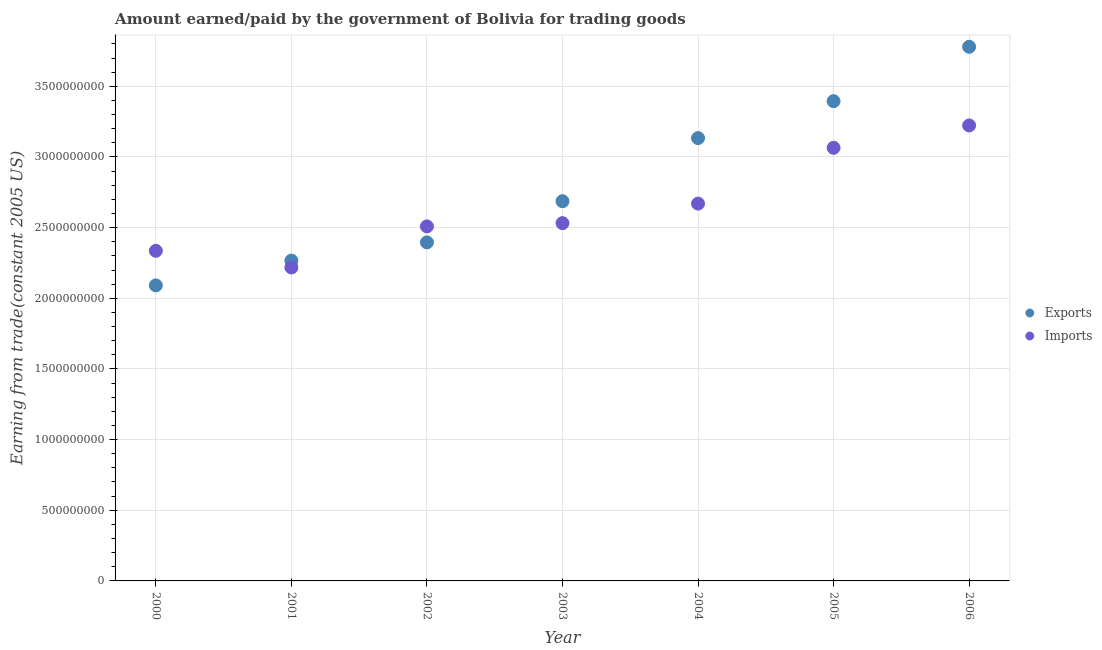Is the number of dotlines equal to the number of legend labels?
Make the answer very short. Yes. What is the amount paid for imports in 2000?
Offer a terse response. 2.34e+09. Across all years, what is the maximum amount paid for imports?
Give a very brief answer. 3.22e+09. Across all years, what is the minimum amount paid for imports?
Offer a very short reply. 2.22e+09. What is the total amount earned from exports in the graph?
Give a very brief answer. 1.97e+1. What is the difference between the amount paid for imports in 2000 and that in 2001?
Your answer should be compact. 1.18e+08. What is the difference between the amount earned from exports in 2003 and the amount paid for imports in 2002?
Provide a succinct answer. 1.78e+08. What is the average amount paid for imports per year?
Your answer should be compact. 2.65e+09. In the year 2006, what is the difference between the amount earned from exports and amount paid for imports?
Your answer should be compact. 5.57e+08. What is the ratio of the amount paid for imports in 2004 to that in 2005?
Make the answer very short. 0.87. Is the amount paid for imports in 2000 less than that in 2002?
Your response must be concise. Yes. What is the difference between the highest and the second highest amount earned from exports?
Your answer should be compact. 3.85e+08. What is the difference between the highest and the lowest amount earned from exports?
Offer a very short reply. 1.69e+09. Is the sum of the amount paid for imports in 2002 and 2005 greater than the maximum amount earned from exports across all years?
Ensure brevity in your answer.  Yes. Does the amount paid for imports monotonically increase over the years?
Ensure brevity in your answer.  No. How many dotlines are there?
Your answer should be compact. 2. How many years are there in the graph?
Your response must be concise. 7. What is the difference between two consecutive major ticks on the Y-axis?
Your answer should be compact. 5.00e+08. Does the graph contain any zero values?
Offer a very short reply. No. Does the graph contain grids?
Your answer should be very brief. Yes. Where does the legend appear in the graph?
Your response must be concise. Center right. How are the legend labels stacked?
Give a very brief answer. Vertical. What is the title of the graph?
Provide a succinct answer. Amount earned/paid by the government of Bolivia for trading goods. What is the label or title of the Y-axis?
Provide a short and direct response. Earning from trade(constant 2005 US). What is the Earning from trade(constant 2005 US) of Exports in 2000?
Your answer should be compact. 2.09e+09. What is the Earning from trade(constant 2005 US) in Imports in 2000?
Make the answer very short. 2.34e+09. What is the Earning from trade(constant 2005 US) of Exports in 2001?
Ensure brevity in your answer.  2.27e+09. What is the Earning from trade(constant 2005 US) in Imports in 2001?
Keep it short and to the point. 2.22e+09. What is the Earning from trade(constant 2005 US) of Exports in 2002?
Provide a short and direct response. 2.40e+09. What is the Earning from trade(constant 2005 US) of Imports in 2002?
Your answer should be very brief. 2.51e+09. What is the Earning from trade(constant 2005 US) of Exports in 2003?
Provide a succinct answer. 2.69e+09. What is the Earning from trade(constant 2005 US) of Imports in 2003?
Your response must be concise. 2.53e+09. What is the Earning from trade(constant 2005 US) of Exports in 2004?
Your answer should be very brief. 3.13e+09. What is the Earning from trade(constant 2005 US) in Imports in 2004?
Keep it short and to the point. 2.67e+09. What is the Earning from trade(constant 2005 US) in Exports in 2005?
Your answer should be very brief. 3.39e+09. What is the Earning from trade(constant 2005 US) of Imports in 2005?
Give a very brief answer. 3.06e+09. What is the Earning from trade(constant 2005 US) of Exports in 2006?
Make the answer very short. 3.78e+09. What is the Earning from trade(constant 2005 US) in Imports in 2006?
Your response must be concise. 3.22e+09. Across all years, what is the maximum Earning from trade(constant 2005 US) in Exports?
Your answer should be very brief. 3.78e+09. Across all years, what is the maximum Earning from trade(constant 2005 US) of Imports?
Provide a succinct answer. 3.22e+09. Across all years, what is the minimum Earning from trade(constant 2005 US) in Exports?
Your response must be concise. 2.09e+09. Across all years, what is the minimum Earning from trade(constant 2005 US) of Imports?
Provide a succinct answer. 2.22e+09. What is the total Earning from trade(constant 2005 US) in Exports in the graph?
Your response must be concise. 1.97e+1. What is the total Earning from trade(constant 2005 US) of Imports in the graph?
Ensure brevity in your answer.  1.86e+1. What is the difference between the Earning from trade(constant 2005 US) in Exports in 2000 and that in 2001?
Your answer should be compact. -1.75e+08. What is the difference between the Earning from trade(constant 2005 US) of Imports in 2000 and that in 2001?
Your response must be concise. 1.18e+08. What is the difference between the Earning from trade(constant 2005 US) in Exports in 2000 and that in 2002?
Your response must be concise. -3.04e+08. What is the difference between the Earning from trade(constant 2005 US) in Imports in 2000 and that in 2002?
Your response must be concise. -1.73e+08. What is the difference between the Earning from trade(constant 2005 US) in Exports in 2000 and that in 2003?
Give a very brief answer. -5.96e+08. What is the difference between the Earning from trade(constant 2005 US) in Imports in 2000 and that in 2003?
Provide a succinct answer. -1.96e+08. What is the difference between the Earning from trade(constant 2005 US) of Exports in 2000 and that in 2004?
Provide a succinct answer. -1.04e+09. What is the difference between the Earning from trade(constant 2005 US) of Imports in 2000 and that in 2004?
Provide a short and direct response. -3.34e+08. What is the difference between the Earning from trade(constant 2005 US) in Exports in 2000 and that in 2005?
Keep it short and to the point. -1.30e+09. What is the difference between the Earning from trade(constant 2005 US) of Imports in 2000 and that in 2005?
Your answer should be very brief. -7.29e+08. What is the difference between the Earning from trade(constant 2005 US) of Exports in 2000 and that in 2006?
Make the answer very short. -1.69e+09. What is the difference between the Earning from trade(constant 2005 US) in Imports in 2000 and that in 2006?
Make the answer very short. -8.87e+08. What is the difference between the Earning from trade(constant 2005 US) in Exports in 2001 and that in 2002?
Offer a terse response. -1.29e+08. What is the difference between the Earning from trade(constant 2005 US) in Imports in 2001 and that in 2002?
Your response must be concise. -2.90e+08. What is the difference between the Earning from trade(constant 2005 US) of Exports in 2001 and that in 2003?
Make the answer very short. -4.20e+08. What is the difference between the Earning from trade(constant 2005 US) in Imports in 2001 and that in 2003?
Your response must be concise. -3.13e+08. What is the difference between the Earning from trade(constant 2005 US) in Exports in 2001 and that in 2004?
Your answer should be compact. -8.67e+08. What is the difference between the Earning from trade(constant 2005 US) in Imports in 2001 and that in 2004?
Your answer should be very brief. -4.52e+08. What is the difference between the Earning from trade(constant 2005 US) of Exports in 2001 and that in 2005?
Provide a succinct answer. -1.13e+09. What is the difference between the Earning from trade(constant 2005 US) in Imports in 2001 and that in 2005?
Offer a terse response. -8.47e+08. What is the difference between the Earning from trade(constant 2005 US) of Exports in 2001 and that in 2006?
Your answer should be very brief. -1.51e+09. What is the difference between the Earning from trade(constant 2005 US) in Imports in 2001 and that in 2006?
Your answer should be very brief. -1.00e+09. What is the difference between the Earning from trade(constant 2005 US) of Exports in 2002 and that in 2003?
Make the answer very short. -2.91e+08. What is the difference between the Earning from trade(constant 2005 US) of Imports in 2002 and that in 2003?
Your answer should be very brief. -2.30e+07. What is the difference between the Earning from trade(constant 2005 US) of Exports in 2002 and that in 2004?
Give a very brief answer. -7.38e+08. What is the difference between the Earning from trade(constant 2005 US) in Imports in 2002 and that in 2004?
Provide a succinct answer. -1.61e+08. What is the difference between the Earning from trade(constant 2005 US) in Exports in 2002 and that in 2005?
Provide a succinct answer. -9.99e+08. What is the difference between the Earning from trade(constant 2005 US) in Imports in 2002 and that in 2005?
Ensure brevity in your answer.  -5.56e+08. What is the difference between the Earning from trade(constant 2005 US) of Exports in 2002 and that in 2006?
Your answer should be compact. -1.38e+09. What is the difference between the Earning from trade(constant 2005 US) in Imports in 2002 and that in 2006?
Give a very brief answer. -7.14e+08. What is the difference between the Earning from trade(constant 2005 US) of Exports in 2003 and that in 2004?
Make the answer very short. -4.47e+08. What is the difference between the Earning from trade(constant 2005 US) of Imports in 2003 and that in 2004?
Provide a succinct answer. -1.38e+08. What is the difference between the Earning from trade(constant 2005 US) in Exports in 2003 and that in 2005?
Ensure brevity in your answer.  -7.08e+08. What is the difference between the Earning from trade(constant 2005 US) in Imports in 2003 and that in 2005?
Provide a succinct answer. -5.33e+08. What is the difference between the Earning from trade(constant 2005 US) of Exports in 2003 and that in 2006?
Give a very brief answer. -1.09e+09. What is the difference between the Earning from trade(constant 2005 US) in Imports in 2003 and that in 2006?
Offer a very short reply. -6.91e+08. What is the difference between the Earning from trade(constant 2005 US) in Exports in 2004 and that in 2005?
Offer a very short reply. -2.61e+08. What is the difference between the Earning from trade(constant 2005 US) in Imports in 2004 and that in 2005?
Provide a succinct answer. -3.95e+08. What is the difference between the Earning from trade(constant 2005 US) of Exports in 2004 and that in 2006?
Your answer should be compact. -6.46e+08. What is the difference between the Earning from trade(constant 2005 US) of Imports in 2004 and that in 2006?
Offer a terse response. -5.53e+08. What is the difference between the Earning from trade(constant 2005 US) of Exports in 2005 and that in 2006?
Your response must be concise. -3.85e+08. What is the difference between the Earning from trade(constant 2005 US) in Imports in 2005 and that in 2006?
Make the answer very short. -1.58e+08. What is the difference between the Earning from trade(constant 2005 US) of Exports in 2000 and the Earning from trade(constant 2005 US) of Imports in 2001?
Provide a short and direct response. -1.27e+08. What is the difference between the Earning from trade(constant 2005 US) of Exports in 2000 and the Earning from trade(constant 2005 US) of Imports in 2002?
Ensure brevity in your answer.  -4.17e+08. What is the difference between the Earning from trade(constant 2005 US) of Exports in 2000 and the Earning from trade(constant 2005 US) of Imports in 2003?
Offer a very short reply. -4.40e+08. What is the difference between the Earning from trade(constant 2005 US) of Exports in 2000 and the Earning from trade(constant 2005 US) of Imports in 2004?
Offer a very short reply. -5.79e+08. What is the difference between the Earning from trade(constant 2005 US) in Exports in 2000 and the Earning from trade(constant 2005 US) in Imports in 2005?
Keep it short and to the point. -9.73e+08. What is the difference between the Earning from trade(constant 2005 US) in Exports in 2000 and the Earning from trade(constant 2005 US) in Imports in 2006?
Offer a very short reply. -1.13e+09. What is the difference between the Earning from trade(constant 2005 US) of Exports in 2001 and the Earning from trade(constant 2005 US) of Imports in 2002?
Keep it short and to the point. -2.42e+08. What is the difference between the Earning from trade(constant 2005 US) in Exports in 2001 and the Earning from trade(constant 2005 US) in Imports in 2003?
Your response must be concise. -2.65e+08. What is the difference between the Earning from trade(constant 2005 US) of Exports in 2001 and the Earning from trade(constant 2005 US) of Imports in 2004?
Make the answer very short. -4.04e+08. What is the difference between the Earning from trade(constant 2005 US) of Exports in 2001 and the Earning from trade(constant 2005 US) of Imports in 2005?
Your response must be concise. -7.98e+08. What is the difference between the Earning from trade(constant 2005 US) in Exports in 2001 and the Earning from trade(constant 2005 US) in Imports in 2006?
Make the answer very short. -9.56e+08. What is the difference between the Earning from trade(constant 2005 US) in Exports in 2002 and the Earning from trade(constant 2005 US) in Imports in 2003?
Offer a terse response. -1.36e+08. What is the difference between the Earning from trade(constant 2005 US) of Exports in 2002 and the Earning from trade(constant 2005 US) of Imports in 2004?
Give a very brief answer. -2.74e+08. What is the difference between the Earning from trade(constant 2005 US) in Exports in 2002 and the Earning from trade(constant 2005 US) in Imports in 2005?
Keep it short and to the point. -6.69e+08. What is the difference between the Earning from trade(constant 2005 US) of Exports in 2002 and the Earning from trade(constant 2005 US) of Imports in 2006?
Make the answer very short. -8.27e+08. What is the difference between the Earning from trade(constant 2005 US) of Exports in 2003 and the Earning from trade(constant 2005 US) of Imports in 2004?
Provide a succinct answer. 1.69e+07. What is the difference between the Earning from trade(constant 2005 US) of Exports in 2003 and the Earning from trade(constant 2005 US) of Imports in 2005?
Offer a terse response. -3.78e+08. What is the difference between the Earning from trade(constant 2005 US) of Exports in 2003 and the Earning from trade(constant 2005 US) of Imports in 2006?
Provide a succinct answer. -5.36e+08. What is the difference between the Earning from trade(constant 2005 US) in Exports in 2004 and the Earning from trade(constant 2005 US) in Imports in 2005?
Give a very brief answer. 6.87e+07. What is the difference between the Earning from trade(constant 2005 US) of Exports in 2004 and the Earning from trade(constant 2005 US) of Imports in 2006?
Give a very brief answer. -8.95e+07. What is the difference between the Earning from trade(constant 2005 US) in Exports in 2005 and the Earning from trade(constant 2005 US) in Imports in 2006?
Offer a terse response. 1.72e+08. What is the average Earning from trade(constant 2005 US) of Exports per year?
Offer a terse response. 2.82e+09. What is the average Earning from trade(constant 2005 US) of Imports per year?
Offer a terse response. 2.65e+09. In the year 2000, what is the difference between the Earning from trade(constant 2005 US) of Exports and Earning from trade(constant 2005 US) of Imports?
Make the answer very short. -2.45e+08. In the year 2001, what is the difference between the Earning from trade(constant 2005 US) of Exports and Earning from trade(constant 2005 US) of Imports?
Your response must be concise. 4.83e+07. In the year 2002, what is the difference between the Earning from trade(constant 2005 US) of Exports and Earning from trade(constant 2005 US) of Imports?
Your response must be concise. -1.13e+08. In the year 2003, what is the difference between the Earning from trade(constant 2005 US) in Exports and Earning from trade(constant 2005 US) in Imports?
Offer a very short reply. 1.55e+08. In the year 2004, what is the difference between the Earning from trade(constant 2005 US) of Exports and Earning from trade(constant 2005 US) of Imports?
Provide a succinct answer. 4.63e+08. In the year 2005, what is the difference between the Earning from trade(constant 2005 US) in Exports and Earning from trade(constant 2005 US) in Imports?
Your answer should be very brief. 3.30e+08. In the year 2006, what is the difference between the Earning from trade(constant 2005 US) of Exports and Earning from trade(constant 2005 US) of Imports?
Keep it short and to the point. 5.57e+08. What is the ratio of the Earning from trade(constant 2005 US) in Exports in 2000 to that in 2001?
Offer a very short reply. 0.92. What is the ratio of the Earning from trade(constant 2005 US) in Imports in 2000 to that in 2001?
Offer a very short reply. 1.05. What is the ratio of the Earning from trade(constant 2005 US) in Exports in 2000 to that in 2002?
Offer a terse response. 0.87. What is the ratio of the Earning from trade(constant 2005 US) in Imports in 2000 to that in 2002?
Offer a terse response. 0.93. What is the ratio of the Earning from trade(constant 2005 US) in Exports in 2000 to that in 2003?
Make the answer very short. 0.78. What is the ratio of the Earning from trade(constant 2005 US) of Imports in 2000 to that in 2003?
Your response must be concise. 0.92. What is the ratio of the Earning from trade(constant 2005 US) in Exports in 2000 to that in 2004?
Your answer should be compact. 0.67. What is the ratio of the Earning from trade(constant 2005 US) of Imports in 2000 to that in 2004?
Provide a succinct answer. 0.87. What is the ratio of the Earning from trade(constant 2005 US) of Exports in 2000 to that in 2005?
Provide a succinct answer. 0.62. What is the ratio of the Earning from trade(constant 2005 US) in Imports in 2000 to that in 2005?
Your answer should be very brief. 0.76. What is the ratio of the Earning from trade(constant 2005 US) of Exports in 2000 to that in 2006?
Make the answer very short. 0.55. What is the ratio of the Earning from trade(constant 2005 US) of Imports in 2000 to that in 2006?
Give a very brief answer. 0.72. What is the ratio of the Earning from trade(constant 2005 US) in Exports in 2001 to that in 2002?
Ensure brevity in your answer.  0.95. What is the ratio of the Earning from trade(constant 2005 US) in Imports in 2001 to that in 2002?
Your answer should be very brief. 0.88. What is the ratio of the Earning from trade(constant 2005 US) in Exports in 2001 to that in 2003?
Provide a short and direct response. 0.84. What is the ratio of the Earning from trade(constant 2005 US) of Imports in 2001 to that in 2003?
Offer a terse response. 0.88. What is the ratio of the Earning from trade(constant 2005 US) in Exports in 2001 to that in 2004?
Your answer should be very brief. 0.72. What is the ratio of the Earning from trade(constant 2005 US) in Imports in 2001 to that in 2004?
Your answer should be very brief. 0.83. What is the ratio of the Earning from trade(constant 2005 US) of Exports in 2001 to that in 2005?
Your answer should be compact. 0.67. What is the ratio of the Earning from trade(constant 2005 US) of Imports in 2001 to that in 2005?
Your answer should be very brief. 0.72. What is the ratio of the Earning from trade(constant 2005 US) of Exports in 2001 to that in 2006?
Make the answer very short. 0.6. What is the ratio of the Earning from trade(constant 2005 US) in Imports in 2001 to that in 2006?
Ensure brevity in your answer.  0.69. What is the ratio of the Earning from trade(constant 2005 US) in Exports in 2002 to that in 2003?
Provide a short and direct response. 0.89. What is the ratio of the Earning from trade(constant 2005 US) of Imports in 2002 to that in 2003?
Offer a very short reply. 0.99. What is the ratio of the Earning from trade(constant 2005 US) in Exports in 2002 to that in 2004?
Provide a succinct answer. 0.76. What is the ratio of the Earning from trade(constant 2005 US) in Imports in 2002 to that in 2004?
Give a very brief answer. 0.94. What is the ratio of the Earning from trade(constant 2005 US) in Exports in 2002 to that in 2005?
Keep it short and to the point. 0.71. What is the ratio of the Earning from trade(constant 2005 US) of Imports in 2002 to that in 2005?
Provide a succinct answer. 0.82. What is the ratio of the Earning from trade(constant 2005 US) of Exports in 2002 to that in 2006?
Offer a very short reply. 0.63. What is the ratio of the Earning from trade(constant 2005 US) in Imports in 2002 to that in 2006?
Offer a terse response. 0.78. What is the ratio of the Earning from trade(constant 2005 US) in Exports in 2003 to that in 2004?
Your answer should be very brief. 0.86. What is the ratio of the Earning from trade(constant 2005 US) of Imports in 2003 to that in 2004?
Provide a succinct answer. 0.95. What is the ratio of the Earning from trade(constant 2005 US) of Exports in 2003 to that in 2005?
Provide a short and direct response. 0.79. What is the ratio of the Earning from trade(constant 2005 US) of Imports in 2003 to that in 2005?
Your answer should be very brief. 0.83. What is the ratio of the Earning from trade(constant 2005 US) in Exports in 2003 to that in 2006?
Give a very brief answer. 0.71. What is the ratio of the Earning from trade(constant 2005 US) in Imports in 2003 to that in 2006?
Your answer should be compact. 0.79. What is the ratio of the Earning from trade(constant 2005 US) of Imports in 2004 to that in 2005?
Provide a short and direct response. 0.87. What is the ratio of the Earning from trade(constant 2005 US) in Exports in 2004 to that in 2006?
Your answer should be compact. 0.83. What is the ratio of the Earning from trade(constant 2005 US) in Imports in 2004 to that in 2006?
Provide a succinct answer. 0.83. What is the ratio of the Earning from trade(constant 2005 US) in Exports in 2005 to that in 2006?
Provide a succinct answer. 0.9. What is the ratio of the Earning from trade(constant 2005 US) of Imports in 2005 to that in 2006?
Keep it short and to the point. 0.95. What is the difference between the highest and the second highest Earning from trade(constant 2005 US) of Exports?
Your response must be concise. 3.85e+08. What is the difference between the highest and the second highest Earning from trade(constant 2005 US) in Imports?
Provide a succinct answer. 1.58e+08. What is the difference between the highest and the lowest Earning from trade(constant 2005 US) in Exports?
Your response must be concise. 1.69e+09. What is the difference between the highest and the lowest Earning from trade(constant 2005 US) of Imports?
Provide a succinct answer. 1.00e+09. 